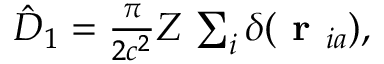Convert formula to latex. <formula><loc_0><loc_0><loc_500><loc_500>\begin{array} { r } { \hat { D } _ { 1 } = \frac { \pi } { 2 c ^ { 2 } } Z \, \sum _ { i } \delta ( r _ { i a } ) , } \end{array}</formula> 